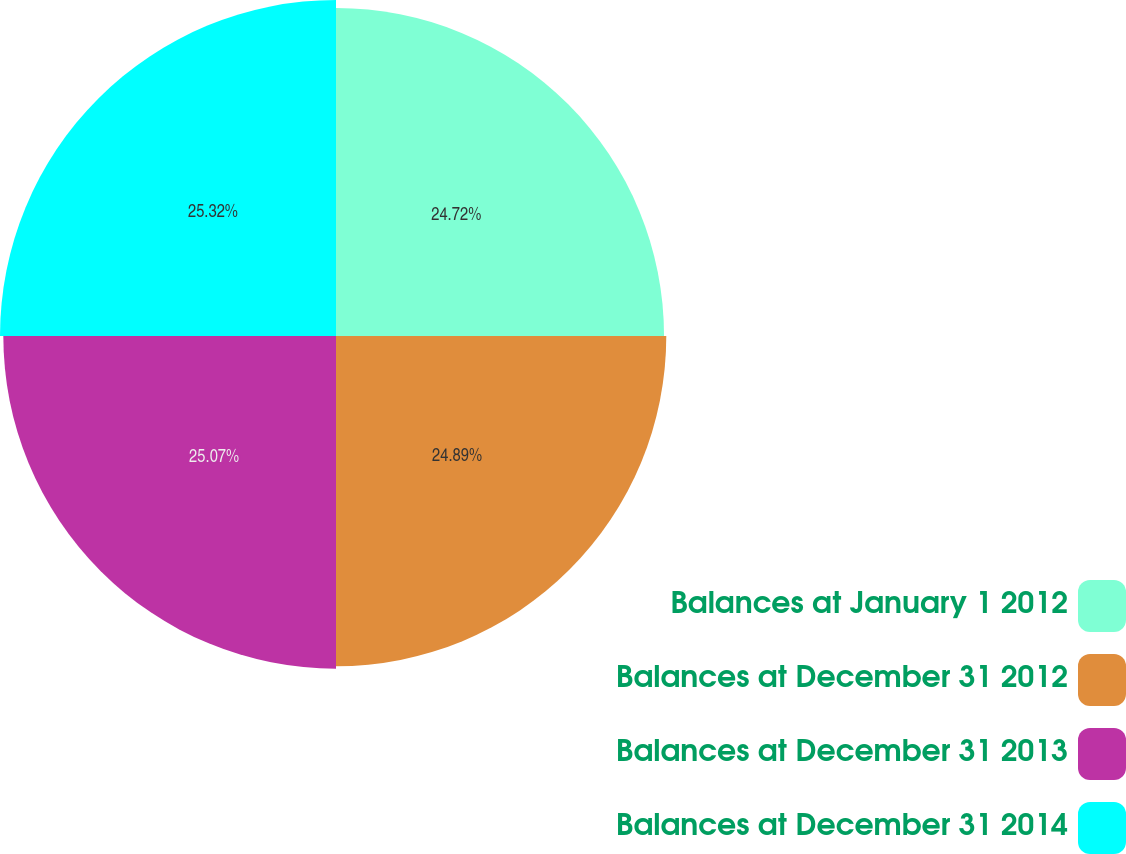Convert chart to OTSL. <chart><loc_0><loc_0><loc_500><loc_500><pie_chart><fcel>Balances at January 1 2012<fcel>Balances at December 31 2012<fcel>Balances at December 31 2013<fcel>Balances at December 31 2014<nl><fcel>24.72%<fcel>24.89%<fcel>25.07%<fcel>25.32%<nl></chart> 